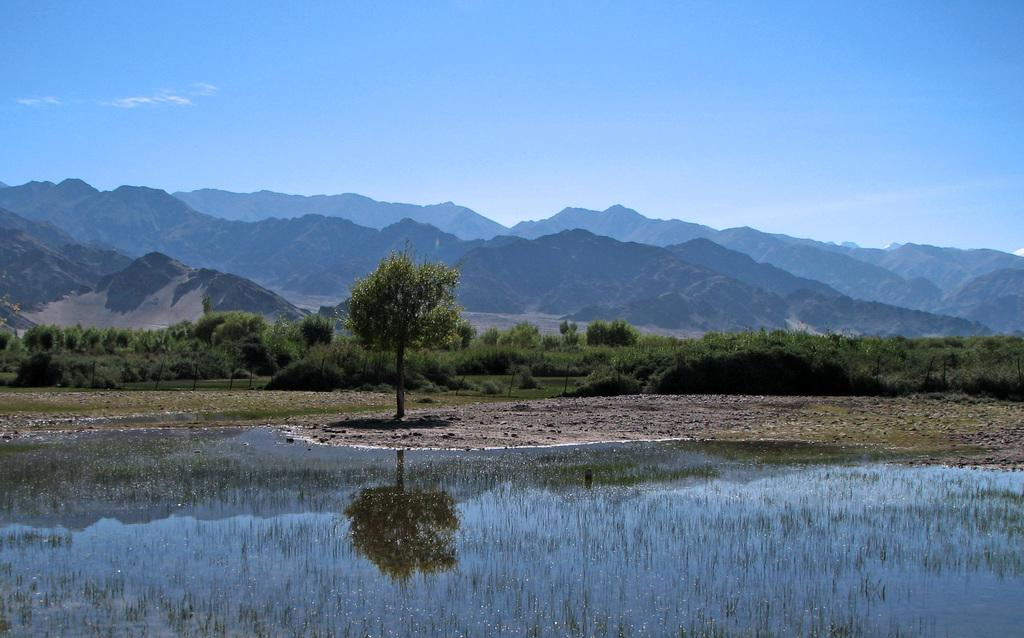What type of natural landform can be seen in the image? There are mountains in the image. What type of vegetation is present in the image? There are trees in the image. What part of the sky is visible in the image? The sky is visible at the top of the image. What part of the ground is visible in the image? The ground is visible at the bottom of the image. What type of water feature is present in the image? There is water in the image. What type of plant life is present in the image? There is grass in the image. How many hands are visible in the image? There are no hands visible in the image. What type of sorting activity is taking place in the image? There is no sorting activity present in the image. 